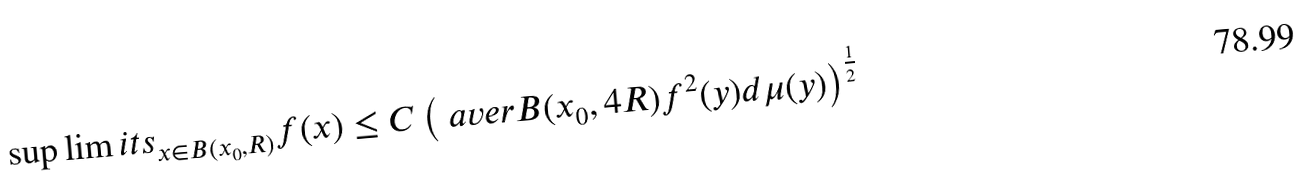<formula> <loc_0><loc_0><loc_500><loc_500>\sup \lim i t s _ { x \in B ( x _ { 0 } , R ) } f ( x ) \leq C \left ( \ a v e r { B ( x _ { 0 } , 4 R ) } f ^ { 2 } ( y ) d \mu ( y ) \right ) ^ { \frac { 1 } { 2 } }</formula> 